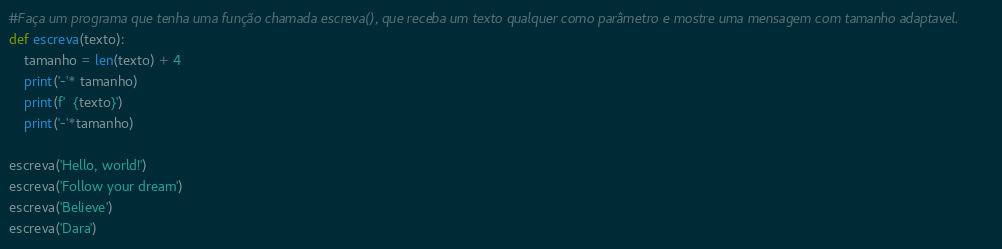Convert code to text. <code><loc_0><loc_0><loc_500><loc_500><_Python_>#Faça um programa que tenha uma função chamada escreva(), que receba um texto qualquer como parâmetro e mostre uma mensagem com tamanho adaptavel.
def escreva(texto):
    tamanho = len(texto) + 4
    print('-'* tamanho)
    print(f'  {texto}')
    print('-'*tamanho)

escreva('Hello, world!')
escreva('Follow your dream')
escreva('Believe')
escreva('Dara')

</code> 